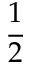Convert formula to latex. <formula><loc_0><loc_0><loc_500><loc_500>\frac { 1 } { 2 }</formula> 